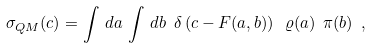<formula> <loc_0><loc_0><loc_500><loc_500>\sigma _ { Q M } ( c ) = \int \, d a \, \int \, d b \ \delta \left ( c - F ( a , b ) \right ) \ \varrho ( a ) \ \pi ( b ) \ ,</formula> 